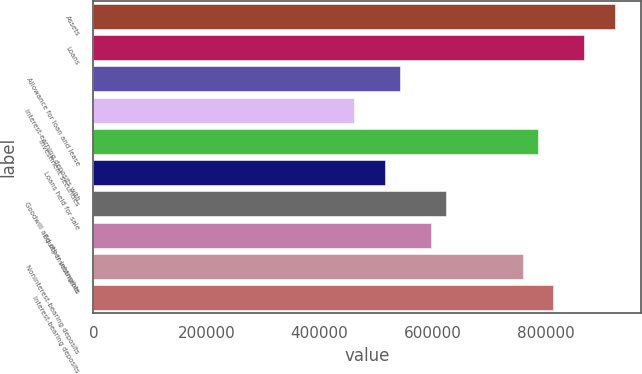Convert chart. <chart><loc_0><loc_0><loc_500><loc_500><bar_chart><fcel>Assets<fcel>Loans<fcel>Allowance for loan and lease<fcel>Interest-earning deposits with<fcel>Investment securities<fcel>Loans held for sale<fcel>Goodwill and other intangible<fcel>Equity investments<fcel>Noninterest-bearing deposits<fcel>Interest-bearing deposits<nl><fcel>922094<fcel>867853<fcel>542409<fcel>461048<fcel>786492<fcel>515288<fcel>623770<fcel>596650<fcel>759372<fcel>813613<nl></chart> 